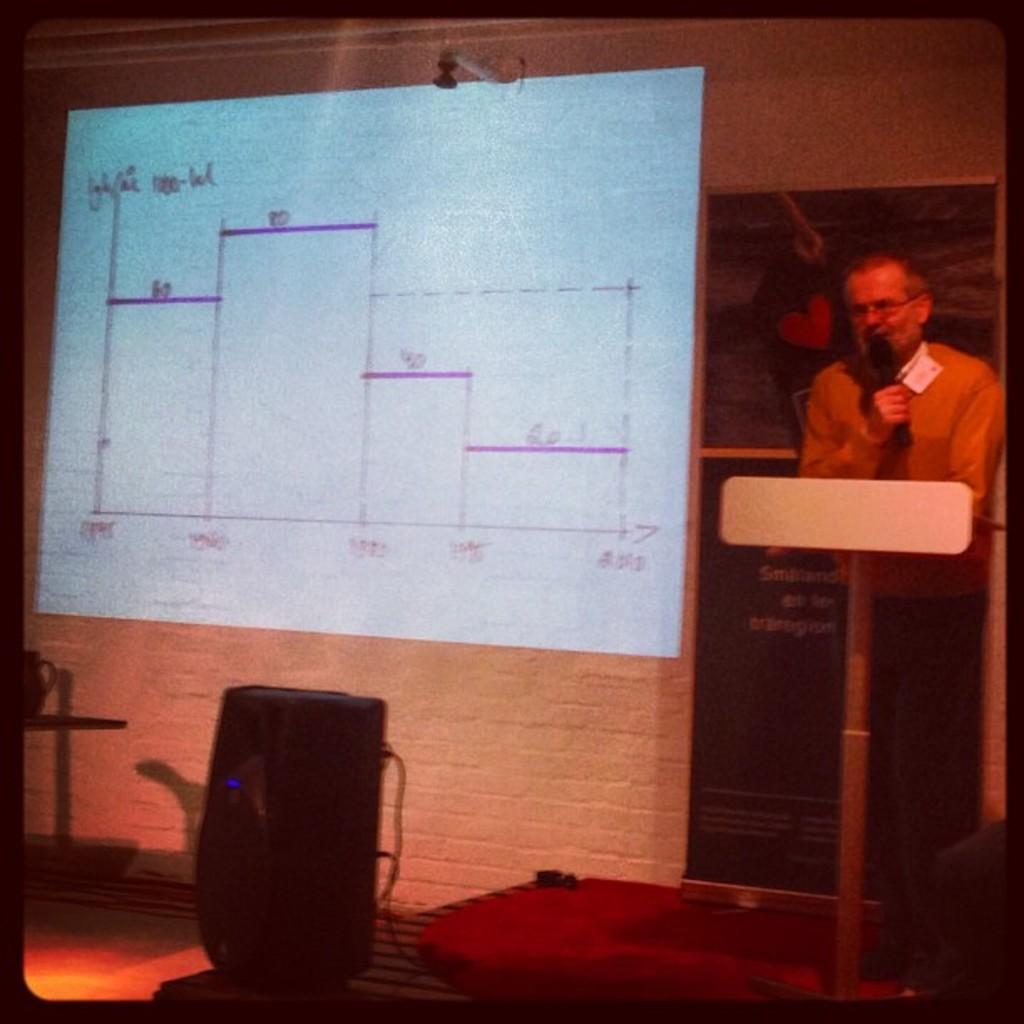In one or two sentences, can you explain what this image depicts? In this image on the right side there is one person who is standing, and he is holding a mike and talking and there is a podium and there is a chair. In the background there is a wall, screen and some boards. At the bottom there is carpet, floor and some other objects. 